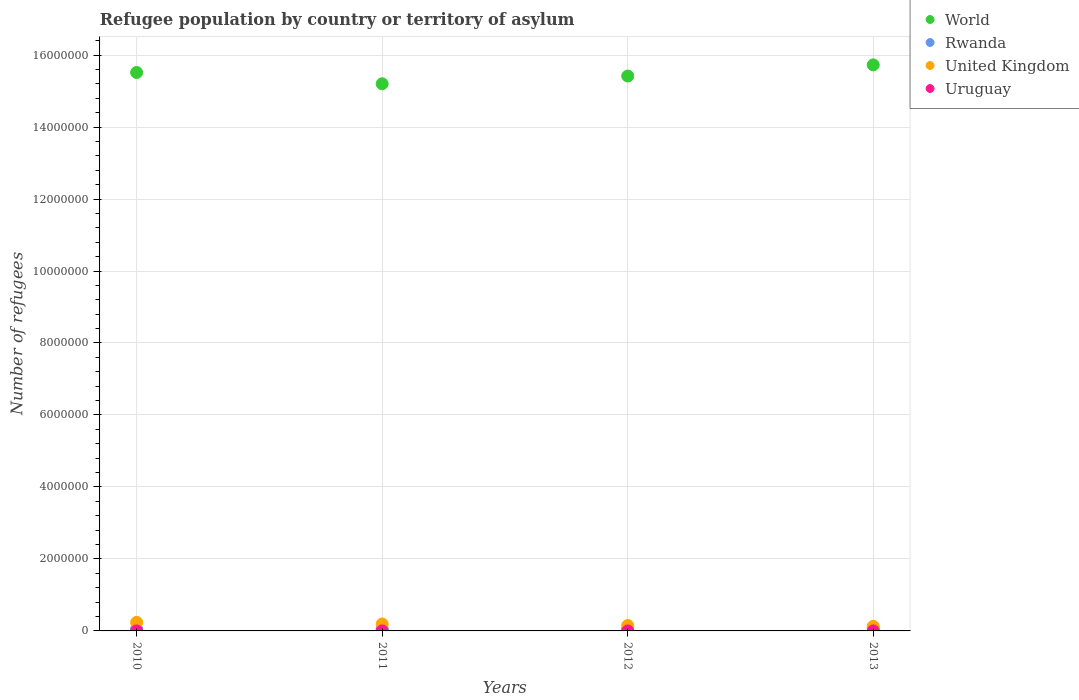How many different coloured dotlines are there?
Your answer should be compact. 4. Is the number of dotlines equal to the number of legend labels?
Your answer should be compact. Yes. What is the number of refugees in World in 2013?
Give a very brief answer. 1.57e+07. Across all years, what is the maximum number of refugees in Uruguay?
Give a very brief answer. 203. Across all years, what is the minimum number of refugees in United Kingdom?
Offer a terse response. 1.26e+05. What is the total number of refugees in Uruguay in the graph?
Your response must be concise. 747. What is the difference between the number of refugees in Rwanda in 2010 and that in 2011?
Keep it short and to the point. 73. What is the difference between the number of refugees in World in 2011 and the number of refugees in Rwanda in 2013?
Provide a short and direct response. 1.51e+07. What is the average number of refugees in World per year?
Offer a terse response. 1.55e+07. In the year 2010, what is the difference between the number of refugees in World and number of refugees in Uruguay?
Provide a short and direct response. 1.55e+07. In how many years, is the number of refugees in Rwanda greater than 9200000?
Offer a terse response. 0. What is the ratio of the number of refugees in United Kingdom in 2010 to that in 2012?
Ensure brevity in your answer.  1.59. Is the number of refugees in Rwanda in 2012 less than that in 2013?
Offer a terse response. Yes. What is the difference between the highest and the second highest number of refugees in World?
Provide a short and direct response. 2.11e+05. What is the difference between the highest and the lowest number of refugees in United Kingdom?
Give a very brief answer. 1.12e+05. In how many years, is the number of refugees in United Kingdom greater than the average number of refugees in United Kingdom taken over all years?
Your answer should be very brief. 2. Is it the case that in every year, the sum of the number of refugees in Uruguay and number of refugees in United Kingdom  is greater than the number of refugees in Rwanda?
Your response must be concise. Yes. How many dotlines are there?
Provide a short and direct response. 4. What is the difference between two consecutive major ticks on the Y-axis?
Give a very brief answer. 2.00e+06. Are the values on the major ticks of Y-axis written in scientific E-notation?
Your response must be concise. No. Does the graph contain any zero values?
Provide a succinct answer. No. Where does the legend appear in the graph?
Make the answer very short. Top right. What is the title of the graph?
Your answer should be compact. Refugee population by country or territory of asylum. Does "Sint Maarten (Dutch part)" appear as one of the legend labels in the graph?
Provide a succinct answer. No. What is the label or title of the X-axis?
Your answer should be very brief. Years. What is the label or title of the Y-axis?
Make the answer very short. Number of refugees. What is the Number of refugees of World in 2010?
Provide a short and direct response. 1.55e+07. What is the Number of refugees of Rwanda in 2010?
Ensure brevity in your answer.  5.54e+04. What is the Number of refugees of United Kingdom in 2010?
Give a very brief answer. 2.38e+05. What is the Number of refugees in Uruguay in 2010?
Your answer should be very brief. 189. What is the Number of refugees in World in 2011?
Your answer should be compact. 1.52e+07. What is the Number of refugees in Rwanda in 2011?
Give a very brief answer. 5.53e+04. What is the Number of refugees in United Kingdom in 2011?
Make the answer very short. 1.94e+05. What is the Number of refugees in Uruguay in 2011?
Offer a very short reply. 174. What is the Number of refugees in World in 2012?
Keep it short and to the point. 1.54e+07. What is the Number of refugees of Rwanda in 2012?
Provide a short and direct response. 5.82e+04. What is the Number of refugees in United Kingdom in 2012?
Give a very brief answer. 1.50e+05. What is the Number of refugees in Uruguay in 2012?
Offer a very short reply. 181. What is the Number of refugees in World in 2013?
Make the answer very short. 1.57e+07. What is the Number of refugees of Rwanda in 2013?
Your response must be concise. 7.33e+04. What is the Number of refugees in United Kingdom in 2013?
Provide a short and direct response. 1.26e+05. What is the Number of refugees in Uruguay in 2013?
Your answer should be very brief. 203. Across all years, what is the maximum Number of refugees in World?
Offer a very short reply. 1.57e+07. Across all years, what is the maximum Number of refugees of Rwanda?
Keep it short and to the point. 7.33e+04. Across all years, what is the maximum Number of refugees of United Kingdom?
Offer a terse response. 2.38e+05. Across all years, what is the maximum Number of refugees of Uruguay?
Provide a succinct answer. 203. Across all years, what is the minimum Number of refugees of World?
Provide a succinct answer. 1.52e+07. Across all years, what is the minimum Number of refugees of Rwanda?
Make the answer very short. 5.53e+04. Across all years, what is the minimum Number of refugees of United Kingdom?
Your response must be concise. 1.26e+05. Across all years, what is the minimum Number of refugees in Uruguay?
Your answer should be very brief. 174. What is the total Number of refugees of World in the graph?
Provide a succinct answer. 6.19e+07. What is the total Number of refugees of Rwanda in the graph?
Provide a succinct answer. 2.42e+05. What is the total Number of refugees of United Kingdom in the graph?
Your answer should be compact. 7.08e+05. What is the total Number of refugees in Uruguay in the graph?
Offer a very short reply. 747. What is the difference between the Number of refugees of World in 2010 and that in 2011?
Offer a terse response. 3.14e+05. What is the difference between the Number of refugees of Rwanda in 2010 and that in 2011?
Offer a terse response. 73. What is the difference between the Number of refugees in United Kingdom in 2010 and that in 2011?
Provide a succinct answer. 4.46e+04. What is the difference between the Number of refugees in World in 2010 and that in 2012?
Offer a terse response. 9.85e+04. What is the difference between the Number of refugees of Rwanda in 2010 and that in 2012?
Provide a succinct answer. -2814. What is the difference between the Number of refugees of United Kingdom in 2010 and that in 2012?
Keep it short and to the point. 8.84e+04. What is the difference between the Number of refugees of Uruguay in 2010 and that in 2012?
Make the answer very short. 8. What is the difference between the Number of refugees in World in 2010 and that in 2013?
Offer a terse response. -2.11e+05. What is the difference between the Number of refugees of Rwanda in 2010 and that in 2013?
Your answer should be compact. -1.80e+04. What is the difference between the Number of refugees of United Kingdom in 2010 and that in 2013?
Your response must be concise. 1.12e+05. What is the difference between the Number of refugees in World in 2011 and that in 2012?
Offer a terse response. -2.15e+05. What is the difference between the Number of refugees in Rwanda in 2011 and that in 2012?
Your answer should be compact. -2887. What is the difference between the Number of refugees of United Kingdom in 2011 and that in 2012?
Provide a short and direct response. 4.37e+04. What is the difference between the Number of refugees of Uruguay in 2011 and that in 2012?
Make the answer very short. -7. What is the difference between the Number of refugees in World in 2011 and that in 2013?
Your answer should be compact. -5.25e+05. What is the difference between the Number of refugees in Rwanda in 2011 and that in 2013?
Your answer should be very brief. -1.80e+04. What is the difference between the Number of refugees in United Kingdom in 2011 and that in 2013?
Ensure brevity in your answer.  6.75e+04. What is the difference between the Number of refugees in World in 2012 and that in 2013?
Ensure brevity in your answer.  -3.10e+05. What is the difference between the Number of refugees of Rwanda in 2012 and that in 2013?
Keep it short and to the point. -1.51e+04. What is the difference between the Number of refugees of United Kingdom in 2012 and that in 2013?
Your answer should be compact. 2.37e+04. What is the difference between the Number of refugees in Uruguay in 2012 and that in 2013?
Provide a succinct answer. -22. What is the difference between the Number of refugees in World in 2010 and the Number of refugees in Rwanda in 2011?
Keep it short and to the point. 1.55e+07. What is the difference between the Number of refugees in World in 2010 and the Number of refugees in United Kingdom in 2011?
Your answer should be compact. 1.53e+07. What is the difference between the Number of refugees in World in 2010 and the Number of refugees in Uruguay in 2011?
Offer a very short reply. 1.55e+07. What is the difference between the Number of refugees of Rwanda in 2010 and the Number of refugees of United Kingdom in 2011?
Keep it short and to the point. -1.38e+05. What is the difference between the Number of refugees of Rwanda in 2010 and the Number of refugees of Uruguay in 2011?
Keep it short and to the point. 5.52e+04. What is the difference between the Number of refugees in United Kingdom in 2010 and the Number of refugees in Uruguay in 2011?
Keep it short and to the point. 2.38e+05. What is the difference between the Number of refugees of World in 2010 and the Number of refugees of Rwanda in 2012?
Your response must be concise. 1.55e+07. What is the difference between the Number of refugees in World in 2010 and the Number of refugees in United Kingdom in 2012?
Make the answer very short. 1.54e+07. What is the difference between the Number of refugees of World in 2010 and the Number of refugees of Uruguay in 2012?
Keep it short and to the point. 1.55e+07. What is the difference between the Number of refugees of Rwanda in 2010 and the Number of refugees of United Kingdom in 2012?
Offer a terse response. -9.44e+04. What is the difference between the Number of refugees of Rwanda in 2010 and the Number of refugees of Uruguay in 2012?
Ensure brevity in your answer.  5.52e+04. What is the difference between the Number of refugees in United Kingdom in 2010 and the Number of refugees in Uruguay in 2012?
Keep it short and to the point. 2.38e+05. What is the difference between the Number of refugees in World in 2010 and the Number of refugees in Rwanda in 2013?
Keep it short and to the point. 1.54e+07. What is the difference between the Number of refugees in World in 2010 and the Number of refugees in United Kingdom in 2013?
Ensure brevity in your answer.  1.54e+07. What is the difference between the Number of refugees of World in 2010 and the Number of refugees of Uruguay in 2013?
Your response must be concise. 1.55e+07. What is the difference between the Number of refugees of Rwanda in 2010 and the Number of refugees of United Kingdom in 2013?
Provide a short and direct response. -7.07e+04. What is the difference between the Number of refugees in Rwanda in 2010 and the Number of refugees in Uruguay in 2013?
Make the answer very short. 5.52e+04. What is the difference between the Number of refugees in United Kingdom in 2010 and the Number of refugees in Uruguay in 2013?
Give a very brief answer. 2.38e+05. What is the difference between the Number of refugees in World in 2011 and the Number of refugees in Rwanda in 2012?
Ensure brevity in your answer.  1.51e+07. What is the difference between the Number of refugees of World in 2011 and the Number of refugees of United Kingdom in 2012?
Your answer should be compact. 1.51e+07. What is the difference between the Number of refugees of World in 2011 and the Number of refugees of Uruguay in 2012?
Offer a terse response. 1.52e+07. What is the difference between the Number of refugees of Rwanda in 2011 and the Number of refugees of United Kingdom in 2012?
Provide a succinct answer. -9.45e+04. What is the difference between the Number of refugees in Rwanda in 2011 and the Number of refugees in Uruguay in 2012?
Give a very brief answer. 5.51e+04. What is the difference between the Number of refugees in United Kingdom in 2011 and the Number of refugees in Uruguay in 2012?
Your answer should be compact. 1.93e+05. What is the difference between the Number of refugees in World in 2011 and the Number of refugees in Rwanda in 2013?
Provide a succinct answer. 1.51e+07. What is the difference between the Number of refugees in World in 2011 and the Number of refugees in United Kingdom in 2013?
Keep it short and to the point. 1.51e+07. What is the difference between the Number of refugees in World in 2011 and the Number of refugees in Uruguay in 2013?
Offer a terse response. 1.52e+07. What is the difference between the Number of refugees in Rwanda in 2011 and the Number of refugees in United Kingdom in 2013?
Offer a terse response. -7.07e+04. What is the difference between the Number of refugees of Rwanda in 2011 and the Number of refugees of Uruguay in 2013?
Offer a terse response. 5.51e+04. What is the difference between the Number of refugees in United Kingdom in 2011 and the Number of refugees in Uruguay in 2013?
Ensure brevity in your answer.  1.93e+05. What is the difference between the Number of refugees of World in 2012 and the Number of refugees of Rwanda in 2013?
Make the answer very short. 1.53e+07. What is the difference between the Number of refugees of World in 2012 and the Number of refugees of United Kingdom in 2013?
Keep it short and to the point. 1.53e+07. What is the difference between the Number of refugees in World in 2012 and the Number of refugees in Uruguay in 2013?
Your answer should be very brief. 1.54e+07. What is the difference between the Number of refugees in Rwanda in 2012 and the Number of refugees in United Kingdom in 2013?
Your answer should be very brief. -6.78e+04. What is the difference between the Number of refugees of Rwanda in 2012 and the Number of refugees of Uruguay in 2013?
Offer a very short reply. 5.80e+04. What is the difference between the Number of refugees of United Kingdom in 2012 and the Number of refugees of Uruguay in 2013?
Give a very brief answer. 1.50e+05. What is the average Number of refugees in World per year?
Keep it short and to the point. 1.55e+07. What is the average Number of refugees of Rwanda per year?
Offer a terse response. 6.06e+04. What is the average Number of refugees in United Kingdom per year?
Provide a succinct answer. 1.77e+05. What is the average Number of refugees in Uruguay per year?
Your answer should be compact. 186.75. In the year 2010, what is the difference between the Number of refugees in World and Number of refugees in Rwanda?
Keep it short and to the point. 1.55e+07. In the year 2010, what is the difference between the Number of refugees of World and Number of refugees of United Kingdom?
Provide a succinct answer. 1.53e+07. In the year 2010, what is the difference between the Number of refugees in World and Number of refugees in Uruguay?
Your response must be concise. 1.55e+07. In the year 2010, what is the difference between the Number of refugees in Rwanda and Number of refugees in United Kingdom?
Offer a terse response. -1.83e+05. In the year 2010, what is the difference between the Number of refugees of Rwanda and Number of refugees of Uruguay?
Provide a succinct answer. 5.52e+04. In the year 2010, what is the difference between the Number of refugees of United Kingdom and Number of refugees of Uruguay?
Offer a very short reply. 2.38e+05. In the year 2011, what is the difference between the Number of refugees in World and Number of refugees in Rwanda?
Provide a succinct answer. 1.51e+07. In the year 2011, what is the difference between the Number of refugees of World and Number of refugees of United Kingdom?
Offer a very short reply. 1.50e+07. In the year 2011, what is the difference between the Number of refugees in World and Number of refugees in Uruguay?
Make the answer very short. 1.52e+07. In the year 2011, what is the difference between the Number of refugees of Rwanda and Number of refugees of United Kingdom?
Your answer should be very brief. -1.38e+05. In the year 2011, what is the difference between the Number of refugees in Rwanda and Number of refugees in Uruguay?
Provide a short and direct response. 5.52e+04. In the year 2011, what is the difference between the Number of refugees of United Kingdom and Number of refugees of Uruguay?
Keep it short and to the point. 1.93e+05. In the year 2012, what is the difference between the Number of refugees in World and Number of refugees in Rwanda?
Your answer should be very brief. 1.54e+07. In the year 2012, what is the difference between the Number of refugees in World and Number of refugees in United Kingdom?
Provide a short and direct response. 1.53e+07. In the year 2012, what is the difference between the Number of refugees in World and Number of refugees in Uruguay?
Provide a short and direct response. 1.54e+07. In the year 2012, what is the difference between the Number of refugees of Rwanda and Number of refugees of United Kingdom?
Your answer should be very brief. -9.16e+04. In the year 2012, what is the difference between the Number of refugees of Rwanda and Number of refugees of Uruguay?
Your answer should be compact. 5.80e+04. In the year 2012, what is the difference between the Number of refugees in United Kingdom and Number of refugees in Uruguay?
Ensure brevity in your answer.  1.50e+05. In the year 2013, what is the difference between the Number of refugees of World and Number of refugees of Rwanda?
Make the answer very short. 1.57e+07. In the year 2013, what is the difference between the Number of refugees in World and Number of refugees in United Kingdom?
Your answer should be compact. 1.56e+07. In the year 2013, what is the difference between the Number of refugees in World and Number of refugees in Uruguay?
Your answer should be very brief. 1.57e+07. In the year 2013, what is the difference between the Number of refugees in Rwanda and Number of refugees in United Kingdom?
Your answer should be compact. -5.27e+04. In the year 2013, what is the difference between the Number of refugees of Rwanda and Number of refugees of Uruguay?
Provide a succinct answer. 7.31e+04. In the year 2013, what is the difference between the Number of refugees in United Kingdom and Number of refugees in Uruguay?
Your answer should be very brief. 1.26e+05. What is the ratio of the Number of refugees of World in 2010 to that in 2011?
Keep it short and to the point. 1.02. What is the ratio of the Number of refugees in Rwanda in 2010 to that in 2011?
Offer a very short reply. 1. What is the ratio of the Number of refugees in United Kingdom in 2010 to that in 2011?
Give a very brief answer. 1.23. What is the ratio of the Number of refugees in Uruguay in 2010 to that in 2011?
Provide a short and direct response. 1.09. What is the ratio of the Number of refugees in World in 2010 to that in 2012?
Make the answer very short. 1.01. What is the ratio of the Number of refugees in Rwanda in 2010 to that in 2012?
Ensure brevity in your answer.  0.95. What is the ratio of the Number of refugees of United Kingdom in 2010 to that in 2012?
Make the answer very short. 1.59. What is the ratio of the Number of refugees in Uruguay in 2010 to that in 2012?
Make the answer very short. 1.04. What is the ratio of the Number of refugees of World in 2010 to that in 2013?
Provide a succinct answer. 0.99. What is the ratio of the Number of refugees of Rwanda in 2010 to that in 2013?
Give a very brief answer. 0.76. What is the ratio of the Number of refugees of United Kingdom in 2010 to that in 2013?
Give a very brief answer. 1.89. What is the ratio of the Number of refugees in World in 2011 to that in 2012?
Provide a succinct answer. 0.99. What is the ratio of the Number of refugees in Rwanda in 2011 to that in 2012?
Make the answer very short. 0.95. What is the ratio of the Number of refugees in United Kingdom in 2011 to that in 2012?
Make the answer very short. 1.29. What is the ratio of the Number of refugees in Uruguay in 2011 to that in 2012?
Make the answer very short. 0.96. What is the ratio of the Number of refugees of World in 2011 to that in 2013?
Make the answer very short. 0.97. What is the ratio of the Number of refugees of Rwanda in 2011 to that in 2013?
Provide a short and direct response. 0.75. What is the ratio of the Number of refugees of United Kingdom in 2011 to that in 2013?
Provide a short and direct response. 1.54. What is the ratio of the Number of refugees in World in 2012 to that in 2013?
Your response must be concise. 0.98. What is the ratio of the Number of refugees in Rwanda in 2012 to that in 2013?
Offer a terse response. 0.79. What is the ratio of the Number of refugees in United Kingdom in 2012 to that in 2013?
Provide a succinct answer. 1.19. What is the ratio of the Number of refugees in Uruguay in 2012 to that in 2013?
Offer a very short reply. 0.89. What is the difference between the highest and the second highest Number of refugees of World?
Make the answer very short. 2.11e+05. What is the difference between the highest and the second highest Number of refugees of Rwanda?
Give a very brief answer. 1.51e+04. What is the difference between the highest and the second highest Number of refugees in United Kingdom?
Provide a short and direct response. 4.46e+04. What is the difference between the highest and the second highest Number of refugees in Uruguay?
Keep it short and to the point. 14. What is the difference between the highest and the lowest Number of refugees of World?
Your answer should be compact. 5.25e+05. What is the difference between the highest and the lowest Number of refugees of Rwanda?
Provide a succinct answer. 1.80e+04. What is the difference between the highest and the lowest Number of refugees in United Kingdom?
Keep it short and to the point. 1.12e+05. 